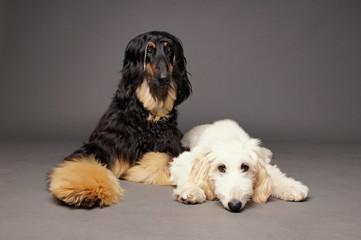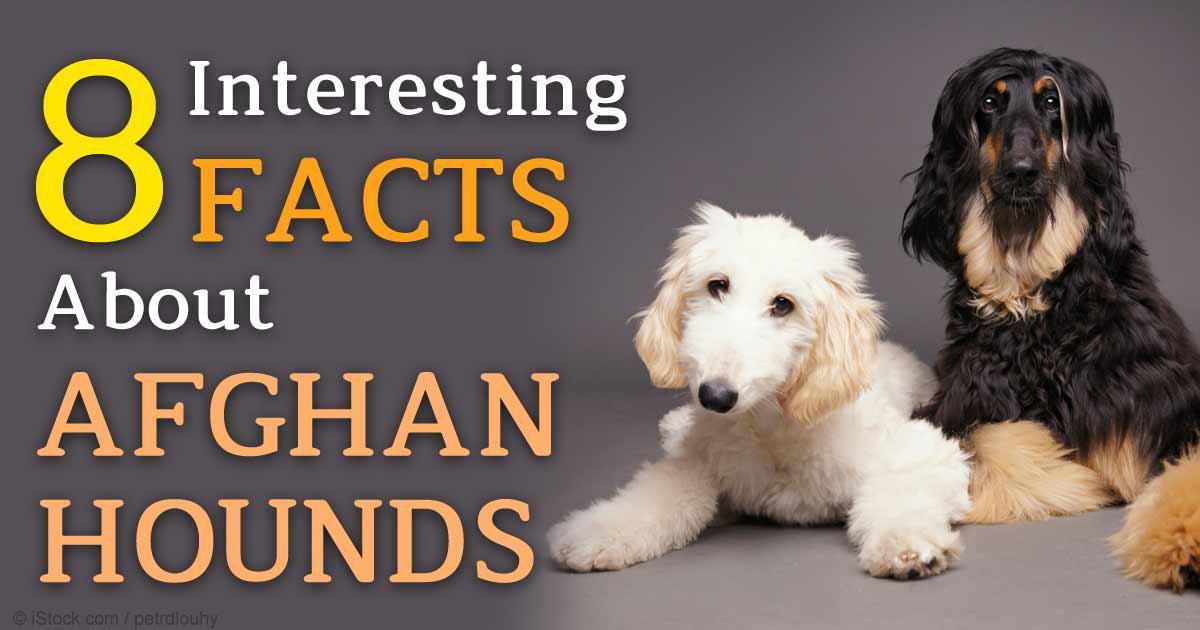The first image is the image on the left, the second image is the image on the right. Evaluate the accuracy of this statement regarding the images: "Each image contains a single afghan hound, no hound is primarily black, and the hound on the left has its curled orange tail visible.". Is it true? Answer yes or no. No. 